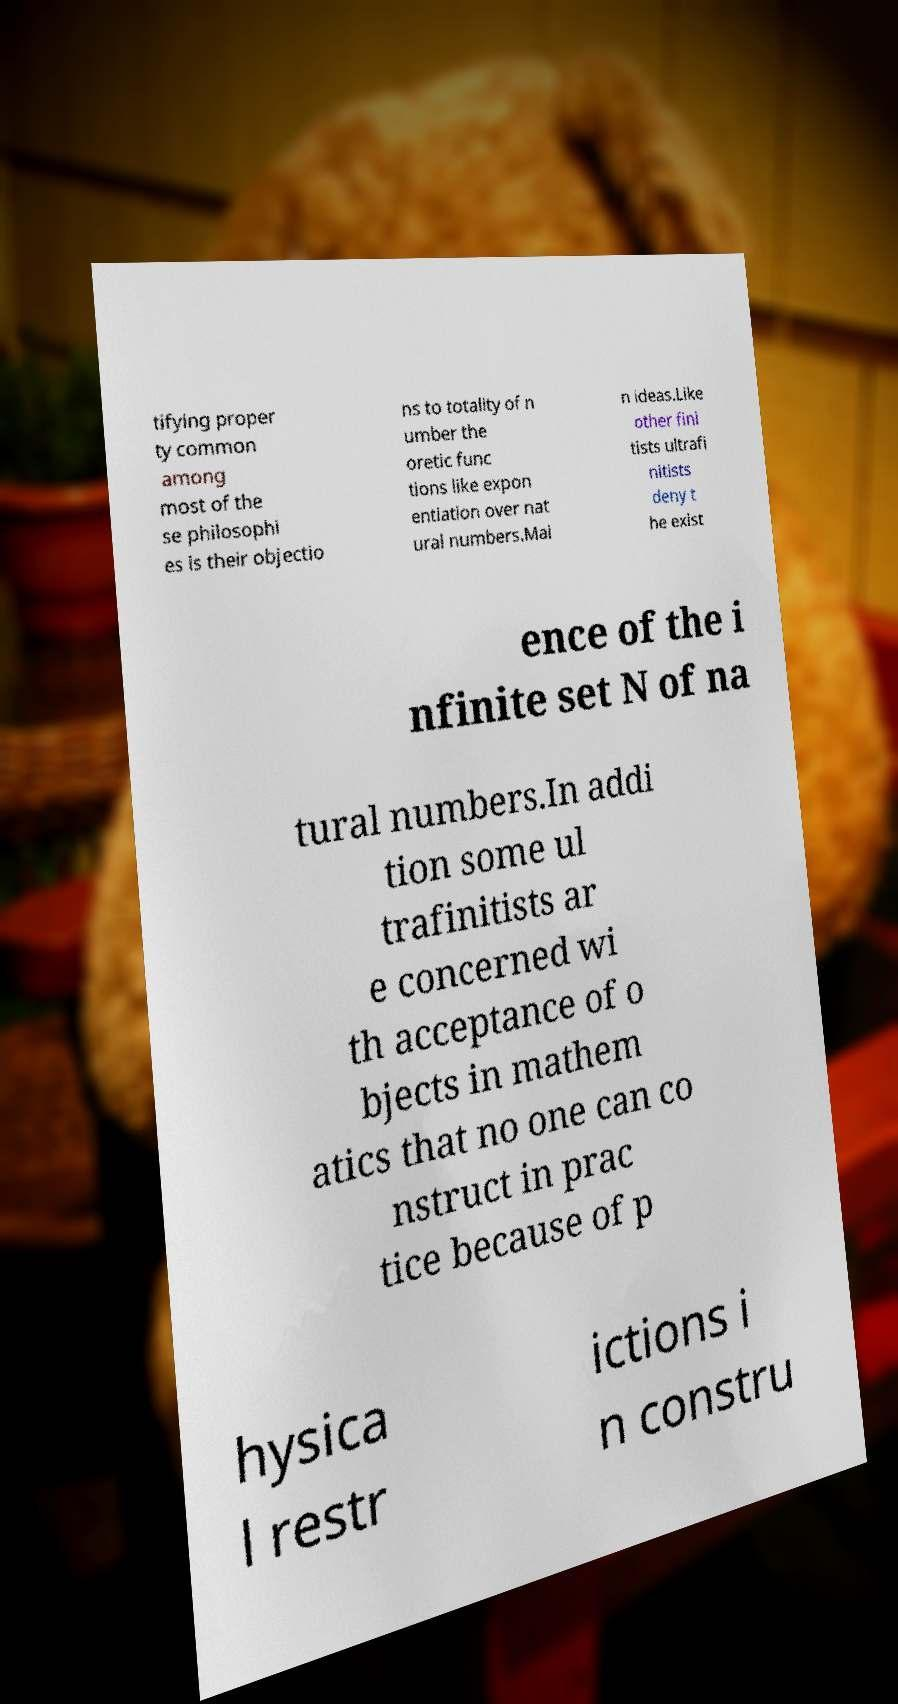Please read and relay the text visible in this image. What does it say? tifying proper ty common among most of the se philosophi es is their objectio ns to totality of n umber the oretic func tions like expon entiation over nat ural numbers.Mai n ideas.Like other fini tists ultrafi nitists deny t he exist ence of the i nfinite set N of na tural numbers.In addi tion some ul trafinitists ar e concerned wi th acceptance of o bjects in mathem atics that no one can co nstruct in prac tice because of p hysica l restr ictions i n constru 